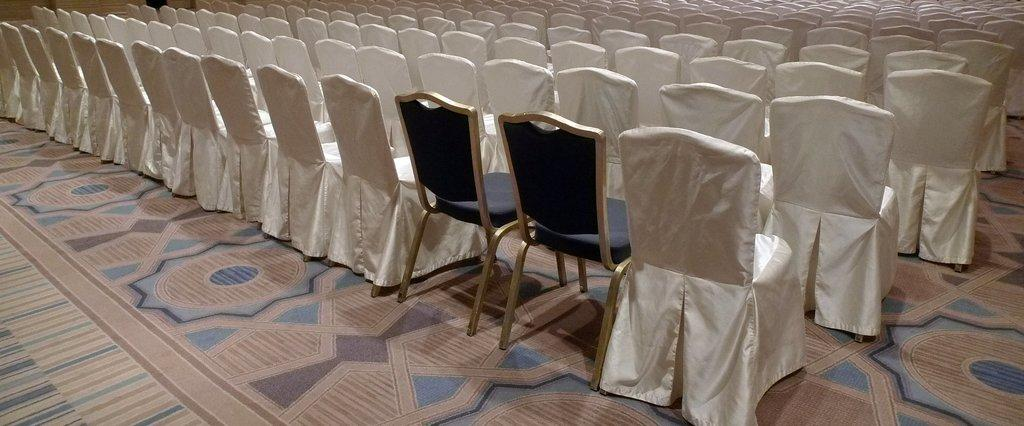What is covering the floor in the image? The floor is covered with a mat. What type of furniture is present on the floor in the image? There are many chairs on the floor. What type of bottle is visible in the image? There is no bottle present in the image. What position are the chairs in the image? The position of the chairs cannot be determined from the image alone, as it only shows the presence of chairs on the floor. How long does it take for the chairs to be arranged in the image? The time it takes to arrange the chairs cannot be determined from the image alone, as it only shows the presence of chairs on the floor. 